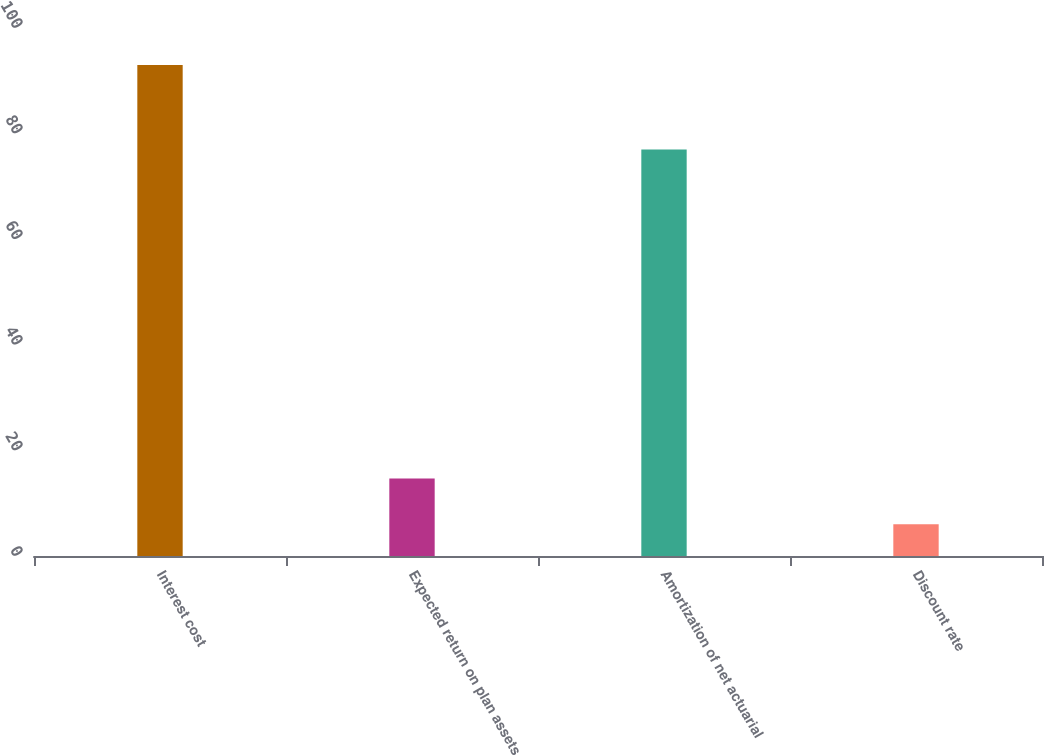Convert chart to OTSL. <chart><loc_0><loc_0><loc_500><loc_500><bar_chart><fcel>Interest cost<fcel>Expected return on plan assets<fcel>Amortization of net actuarial<fcel>Discount rate<nl><fcel>93<fcel>14.7<fcel>77<fcel>6<nl></chart> 